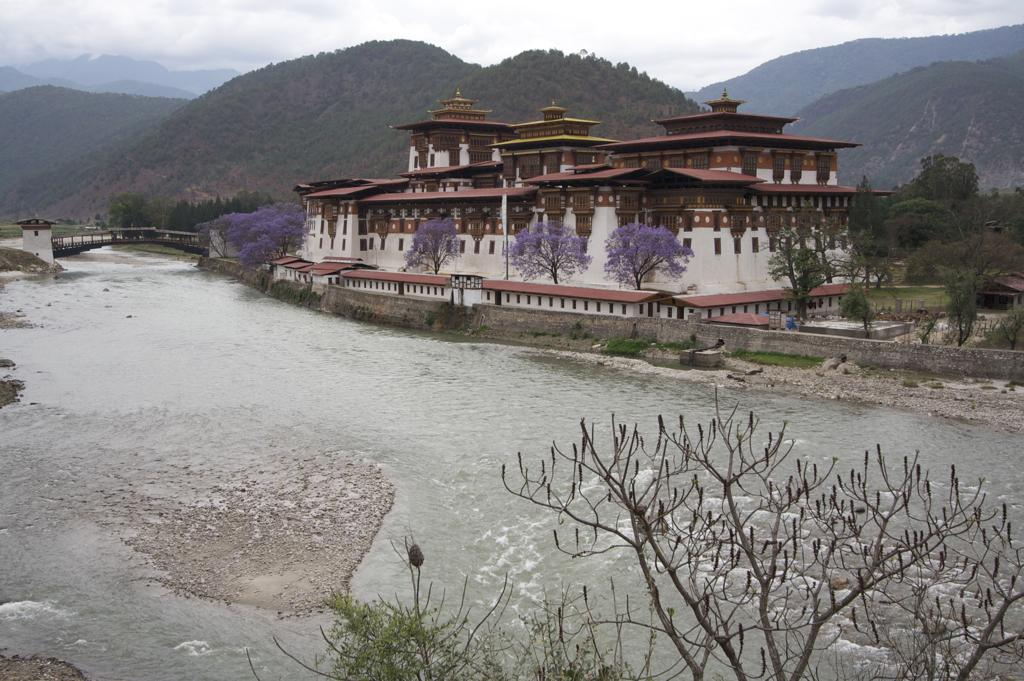What type of water feature is present in the image? There is a floating river in the image. How does the river connect to the surrounding environment? There is a bridge over the river in the image. What type of structure is located near the river? There is a building beside the river in the image. What type of vegetation can be seen in the image? Trees are present in the image. What type of landscape can be seen in the background of the image? There are mountains covered with trees in the image. What scent can be detected coming from the flock of birds in the image? There are no birds or scent present in the image. How many parcels are being delivered by the person in the image? There is no person or parcel present in the image. 